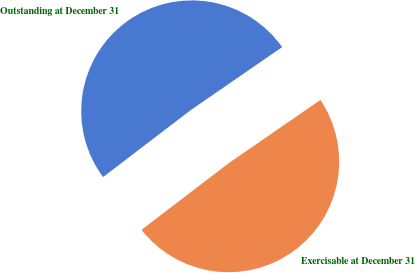Convert chart. <chart><loc_0><loc_0><loc_500><loc_500><pie_chart><fcel>Outstanding at December 31<fcel>Exercisable at December 31<nl><fcel>50.78%<fcel>49.22%<nl></chart> 